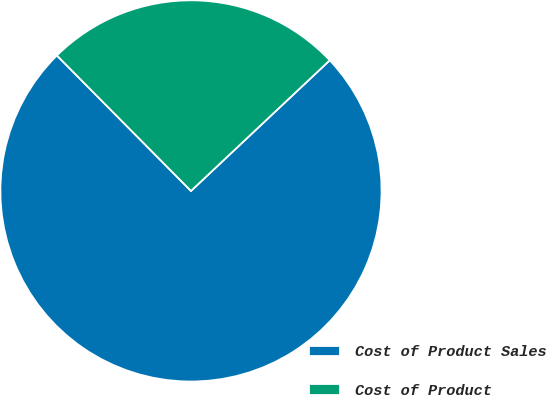Convert chart to OTSL. <chart><loc_0><loc_0><loc_500><loc_500><pie_chart><fcel>Cost of Product Sales<fcel>Cost of Product<nl><fcel>74.6%<fcel>25.4%<nl></chart> 